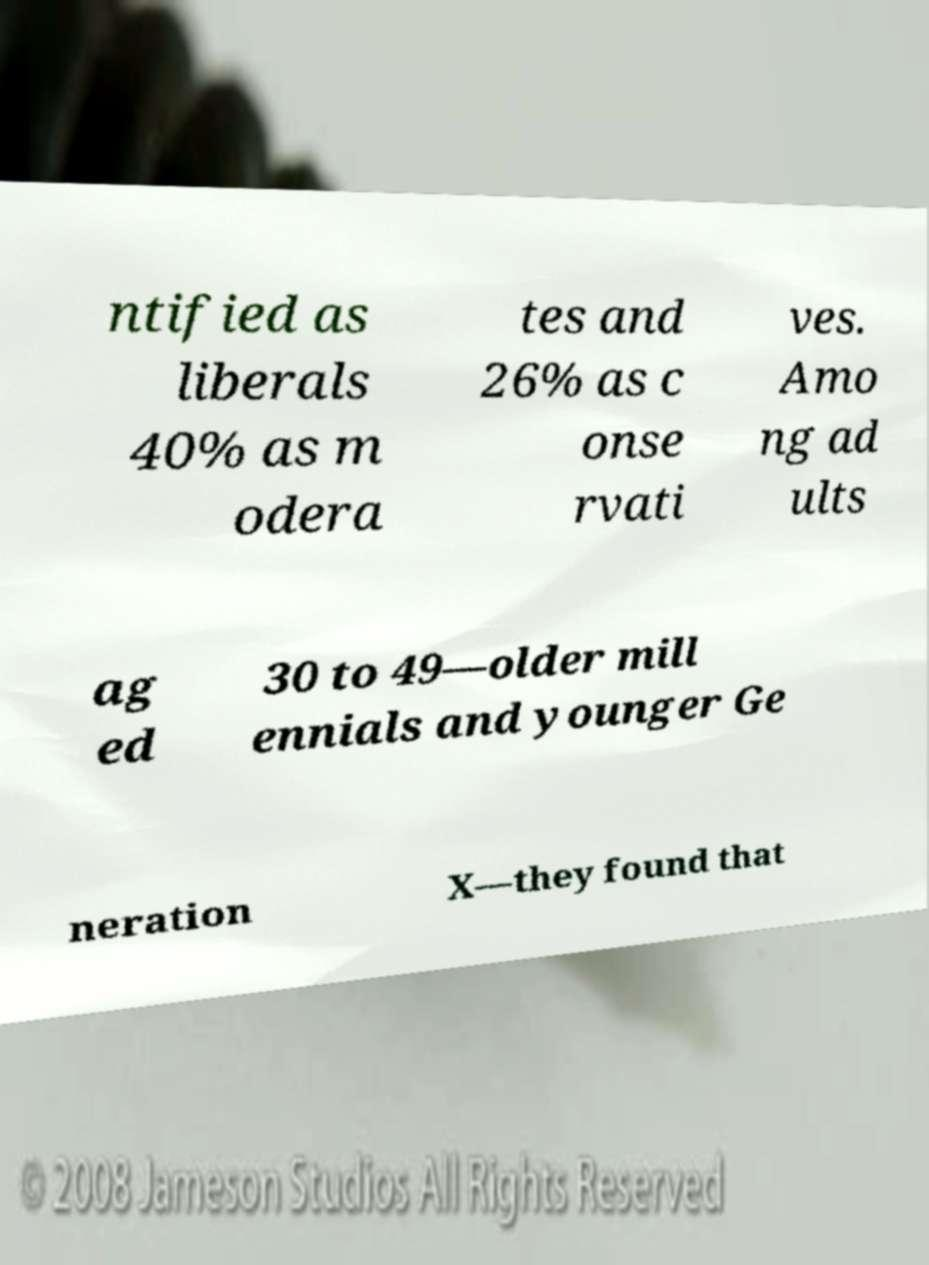Can you read and provide the text displayed in the image?This photo seems to have some interesting text. Can you extract and type it out for me? ntified as liberals 40% as m odera tes and 26% as c onse rvati ves. Amo ng ad ults ag ed 30 to 49—older mill ennials and younger Ge neration X—they found that 